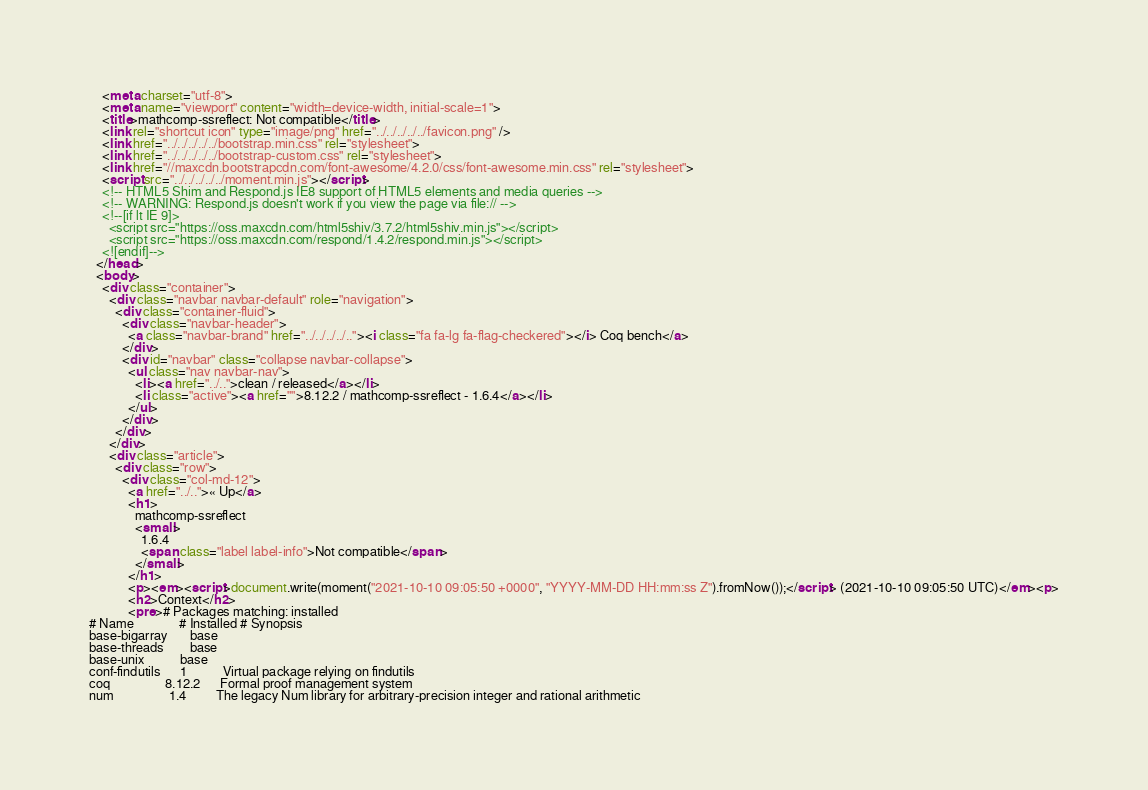Convert code to text. <code><loc_0><loc_0><loc_500><loc_500><_HTML_>    <meta charset="utf-8">
    <meta name="viewport" content="width=device-width, initial-scale=1">
    <title>mathcomp-ssreflect: Not compatible</title>
    <link rel="shortcut icon" type="image/png" href="../../../../../favicon.png" />
    <link href="../../../../../bootstrap.min.css" rel="stylesheet">
    <link href="../../../../../bootstrap-custom.css" rel="stylesheet">
    <link href="//maxcdn.bootstrapcdn.com/font-awesome/4.2.0/css/font-awesome.min.css" rel="stylesheet">
    <script src="../../../../../moment.min.js"></script>
    <!-- HTML5 Shim and Respond.js IE8 support of HTML5 elements and media queries -->
    <!-- WARNING: Respond.js doesn't work if you view the page via file:// -->
    <!--[if lt IE 9]>
      <script src="https://oss.maxcdn.com/html5shiv/3.7.2/html5shiv.min.js"></script>
      <script src="https://oss.maxcdn.com/respond/1.4.2/respond.min.js"></script>
    <![endif]-->
  </head>
  <body>
    <div class="container">
      <div class="navbar navbar-default" role="navigation">
        <div class="container-fluid">
          <div class="navbar-header">
            <a class="navbar-brand" href="../../../../.."><i class="fa fa-lg fa-flag-checkered"></i> Coq bench</a>
          </div>
          <div id="navbar" class="collapse navbar-collapse">
            <ul class="nav navbar-nav">
              <li><a href="../..">clean / released</a></li>
              <li class="active"><a href="">8.12.2 / mathcomp-ssreflect - 1.6.4</a></li>
            </ul>
          </div>
        </div>
      </div>
      <div class="article">
        <div class="row">
          <div class="col-md-12">
            <a href="../..">« Up</a>
            <h1>
              mathcomp-ssreflect
              <small>
                1.6.4
                <span class="label label-info">Not compatible</span>
              </small>
            </h1>
            <p><em><script>document.write(moment("2021-10-10 09:05:50 +0000", "YYYY-MM-DD HH:mm:ss Z").fromNow());</script> (2021-10-10 09:05:50 UTC)</em><p>
            <h2>Context</h2>
            <pre># Packages matching: installed
# Name              # Installed # Synopsis
base-bigarray       base
base-threads        base
base-unix           base
conf-findutils      1           Virtual package relying on findutils
coq                 8.12.2      Formal proof management system
num                 1.4         The legacy Num library for arbitrary-precision integer and rational arithmetic</code> 